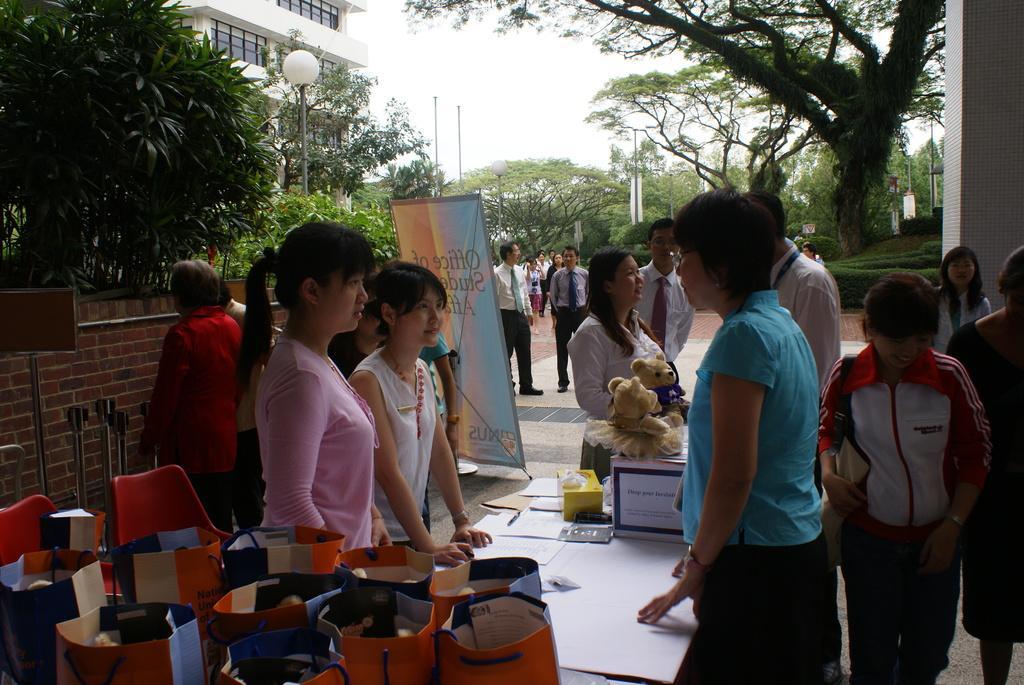In one or two sentences, can you explain what this image depicts? In the top left, building is visible of white in color and sky of white in color. In the middle both side, trees are visible. At the bottom, group of people standing and talking. At the bottom, two chairs are visible of red in color and handbags are visible. This image is taken outside a building in day time. 